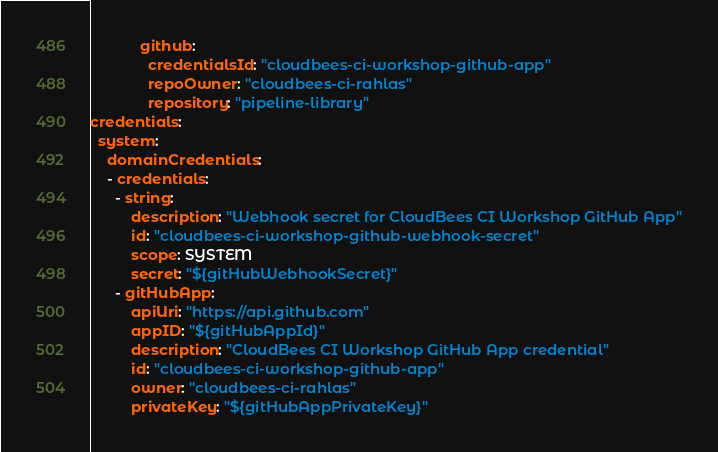Convert code to text. <code><loc_0><loc_0><loc_500><loc_500><_YAML_>            github:
              credentialsId: "cloudbees-ci-workshop-github-app"
              repoOwner: "cloudbees-ci-rahlas"
              repository: "pipeline-library"
credentials:
  system:
    domainCredentials:
    - credentials:
      - string:
          description: "Webhook secret for CloudBees CI Workshop GitHub App"
          id: "cloudbees-ci-workshop-github-webhook-secret"
          scope: SYSTEM
          secret: "${gitHubWebhookSecret}"
      - gitHubApp:
          apiUri: "https://api.github.com"
          appID: "${gitHubAppId}"
          description: "CloudBees CI Workshop GitHub App credential"
          id: "cloudbees-ci-workshop-github-app"
          owner: "cloudbees-ci-rahlas"
          privateKey: "${gitHubAppPrivateKey}"
</code> 